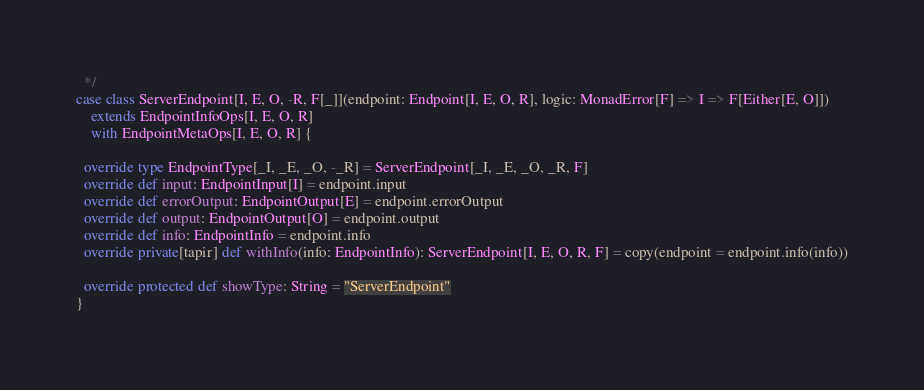Convert code to text. <code><loc_0><loc_0><loc_500><loc_500><_Scala_>  */
case class ServerEndpoint[I, E, O, -R, F[_]](endpoint: Endpoint[I, E, O, R], logic: MonadError[F] => I => F[Either[E, O]])
    extends EndpointInfoOps[I, E, O, R]
    with EndpointMetaOps[I, E, O, R] {

  override type EndpointType[_I, _E, _O, -_R] = ServerEndpoint[_I, _E, _O, _R, F]
  override def input: EndpointInput[I] = endpoint.input
  override def errorOutput: EndpointOutput[E] = endpoint.errorOutput
  override def output: EndpointOutput[O] = endpoint.output
  override def info: EndpointInfo = endpoint.info
  override private[tapir] def withInfo(info: EndpointInfo): ServerEndpoint[I, E, O, R, F] = copy(endpoint = endpoint.info(info))

  override protected def showType: String = "ServerEndpoint"
}
</code> 